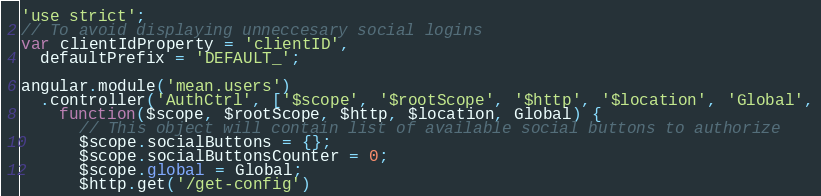<code> <loc_0><loc_0><loc_500><loc_500><_JavaScript_>'use strict';
// To avoid displaying unneccesary social logins
var clientIdProperty = 'clientID',
  defaultPrefix = 'DEFAULT_';

angular.module('mean.users')
  .controller('AuthCtrl', ['$scope', '$rootScope', '$http', '$location', 'Global',
    function($scope, $rootScope, $http, $location, Global) {
      // This object will contain list of available social buttons to authorize
      $scope.socialButtons = {};
      $scope.socialButtonsCounter = 0;
      $scope.global = Global;
      $http.get('/get-config')</code> 